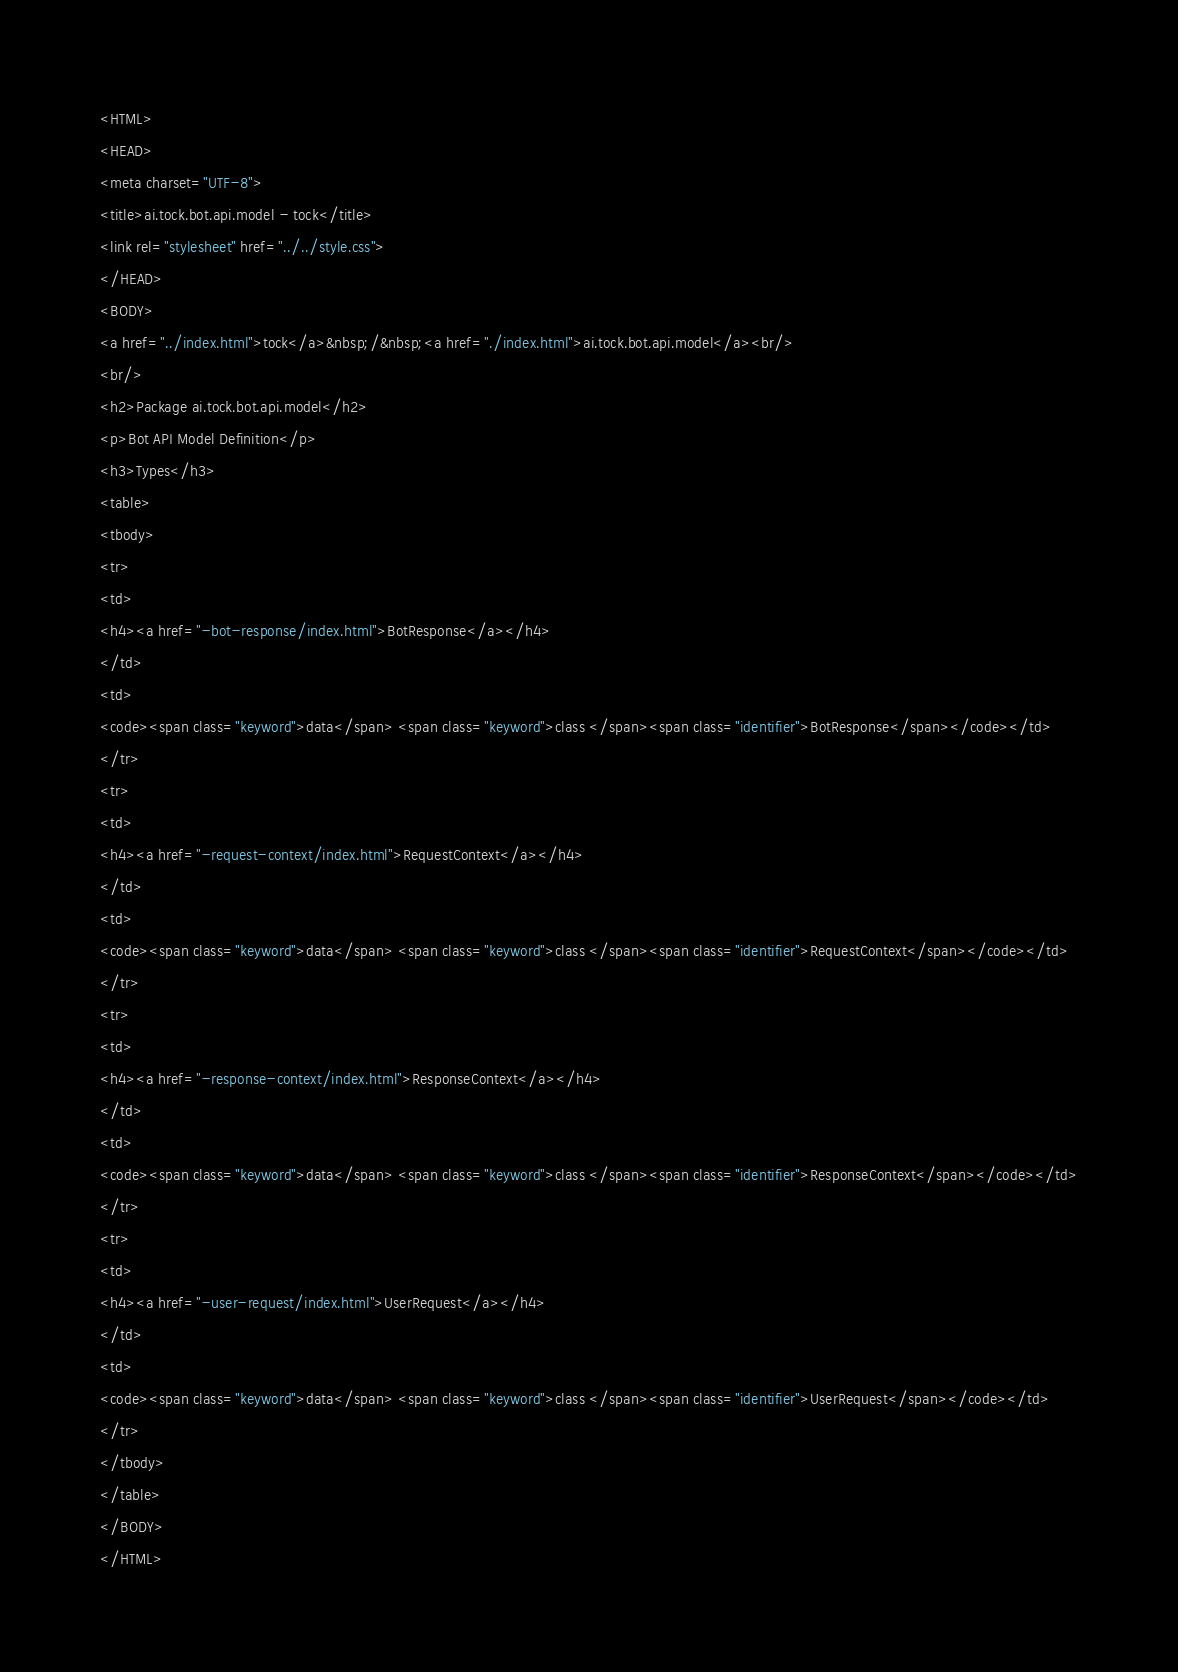Convert code to text. <code><loc_0><loc_0><loc_500><loc_500><_HTML_><HTML>
<HEAD>
<meta charset="UTF-8">
<title>ai.tock.bot.api.model - tock</title>
<link rel="stylesheet" href="../../style.css">
</HEAD>
<BODY>
<a href="../index.html">tock</a>&nbsp;/&nbsp;<a href="./index.html">ai.tock.bot.api.model</a><br/>
<br/>
<h2>Package ai.tock.bot.api.model</h2>
<p>Bot API Model Definition</p>
<h3>Types</h3>
<table>
<tbody>
<tr>
<td>
<h4><a href="-bot-response/index.html">BotResponse</a></h4>
</td>
<td>
<code><span class="keyword">data</span> <span class="keyword">class </span><span class="identifier">BotResponse</span></code></td>
</tr>
<tr>
<td>
<h4><a href="-request-context/index.html">RequestContext</a></h4>
</td>
<td>
<code><span class="keyword">data</span> <span class="keyword">class </span><span class="identifier">RequestContext</span></code></td>
</tr>
<tr>
<td>
<h4><a href="-response-context/index.html">ResponseContext</a></h4>
</td>
<td>
<code><span class="keyword">data</span> <span class="keyword">class </span><span class="identifier">ResponseContext</span></code></td>
</tr>
<tr>
<td>
<h4><a href="-user-request/index.html">UserRequest</a></h4>
</td>
<td>
<code><span class="keyword">data</span> <span class="keyword">class </span><span class="identifier">UserRequest</span></code></td>
</tr>
</tbody>
</table>
</BODY>
</HTML>
</code> 